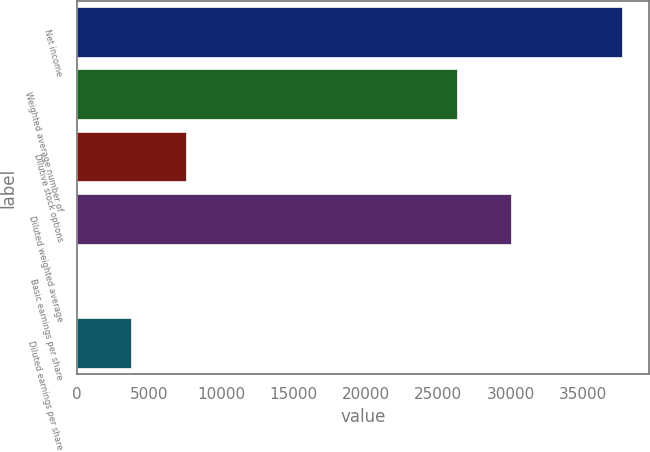<chart> <loc_0><loc_0><loc_500><loc_500><bar_chart><fcel>Net income<fcel>Weighted average number of<fcel>Dilutive stock options<fcel>Diluted weighted average<fcel>Basic earnings per share<fcel>Diluted earnings per share<nl><fcel>37696<fcel>26281<fcel>7540.35<fcel>30050.5<fcel>1.43<fcel>3770.89<nl></chart> 